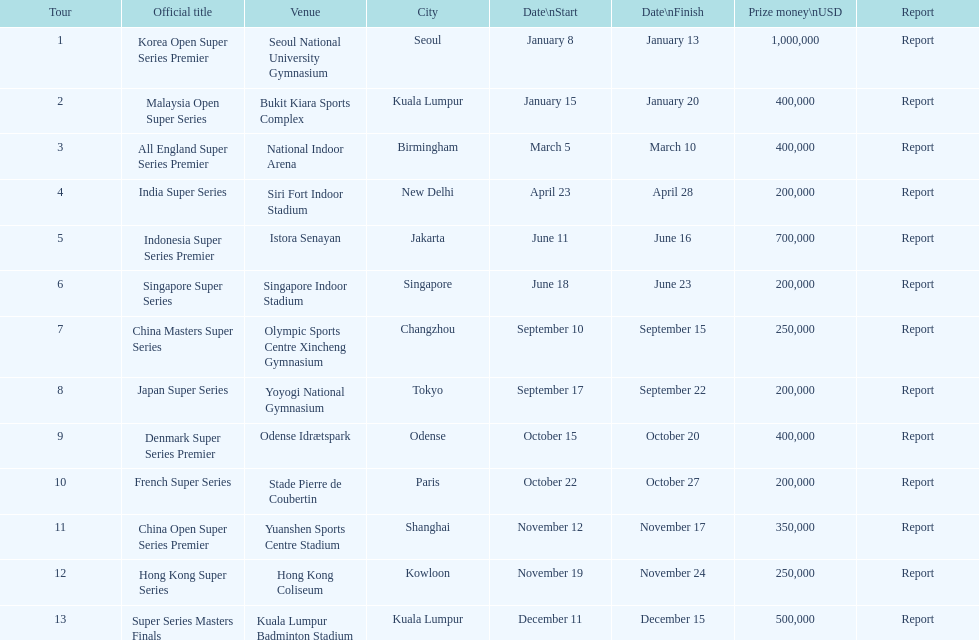How many events of the 2013 bwf super series pay over $200,000? 9. 